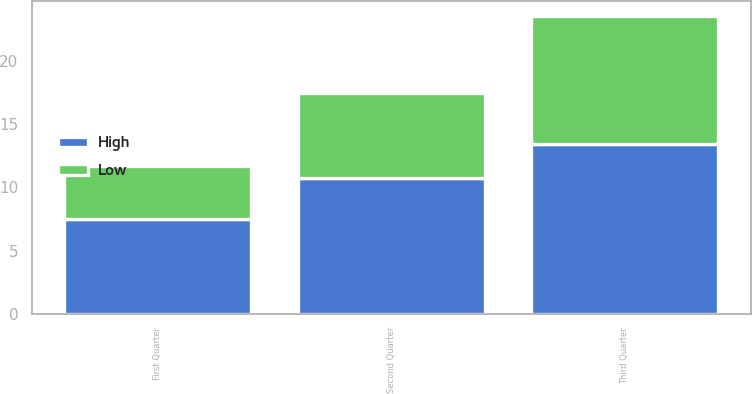Convert chart to OTSL. <chart><loc_0><loc_0><loc_500><loc_500><stacked_bar_chart><ecel><fcel>First Quarter<fcel>Second Quarter<fcel>Third Quarter<nl><fcel>High<fcel>7.5<fcel>10.77<fcel>13.43<nl><fcel>Low<fcel>4.19<fcel>6.66<fcel>10.12<nl></chart> 